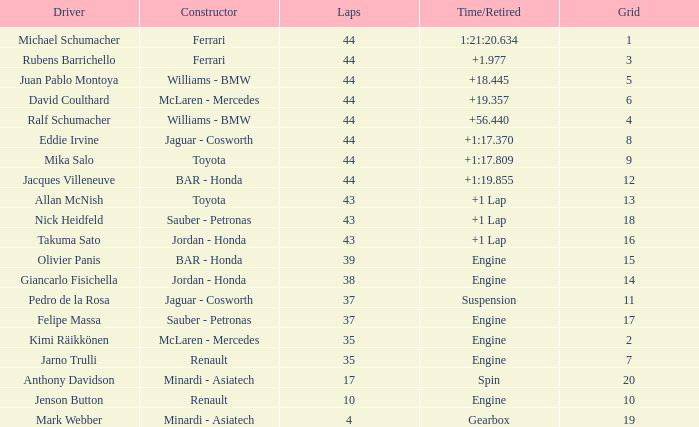What was the finishing time for a person who achieved 43 laps on an 18 grip? +1 Lap. 